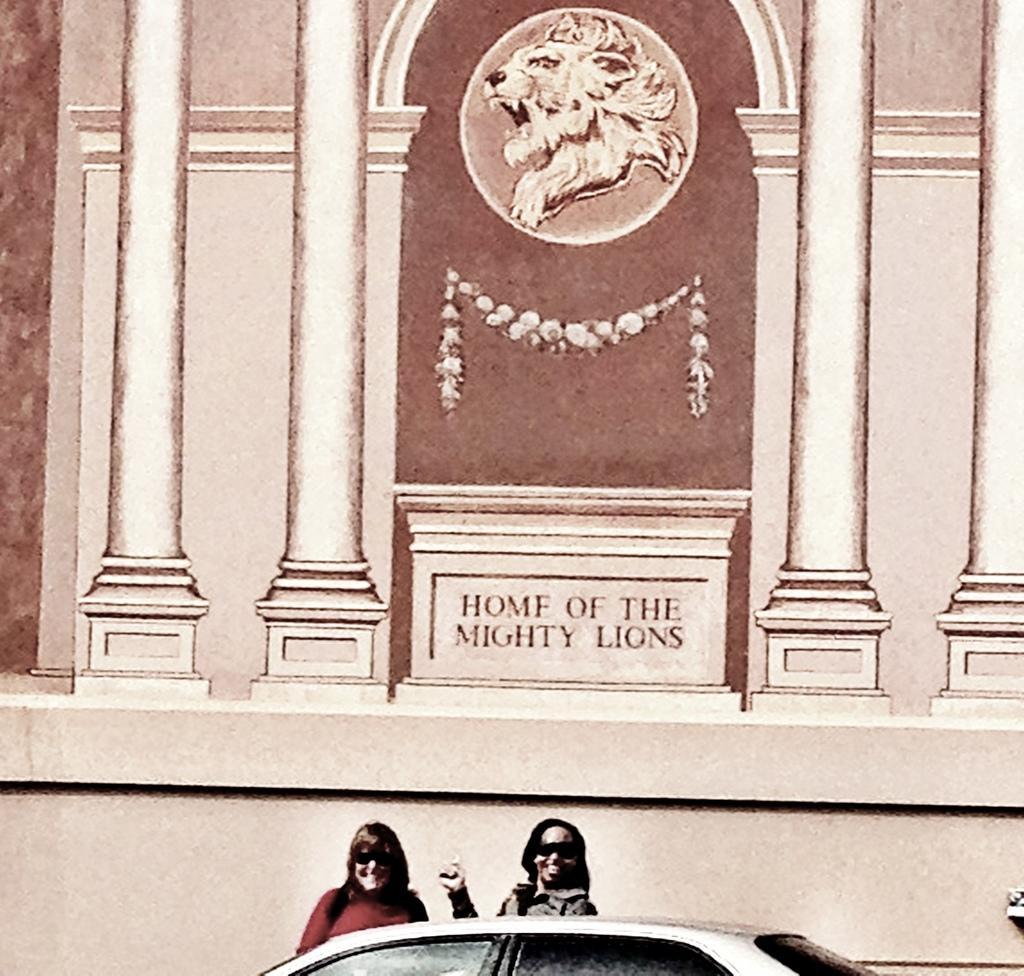In one or two sentences, can you explain what this image depicts? This picture is consists of a posters, which includes the home of a mighty lions and there are two ladies and a car at the bottom side of the image. 